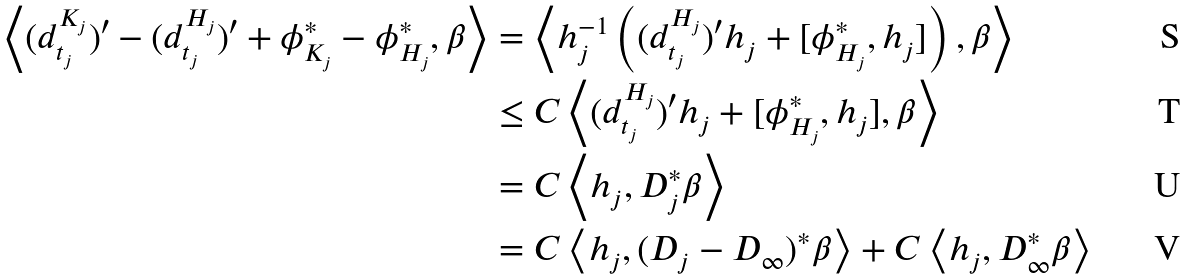Convert formula to latex. <formula><loc_0><loc_0><loc_500><loc_500>\left < ( d _ { t _ { j } } ^ { K _ { j } } ) ^ { \prime } - ( d _ { t _ { j } } ^ { H _ { j } } ) ^ { \prime } + \phi _ { K _ { j } } ^ { * } - \phi _ { H _ { j } } ^ { * } , \beta \right > & = \left < h _ { j } ^ { - 1 } \left ( ( d _ { t _ { j } } ^ { H _ { j } } ) ^ { \prime } h _ { j } + [ \phi _ { H _ { j } } ^ { * } , h _ { j } ] \right ) , \beta \right > \\ & \leq C \left < ( d _ { t _ { j } } ^ { H _ { j } } ) ^ { \prime } h _ { j } + [ \phi _ { H _ { j } } ^ { * } , h _ { j } ] , \beta \right > \\ & = C \left < h _ { j } , D _ { j } ^ { * } \beta \right > \\ & = C \left < h _ { j } , ( D _ { j } - D _ { \infty } ) ^ { * } \beta \right > + C \left < h _ { j } , D _ { \infty } ^ { * } \beta \right ></formula> 